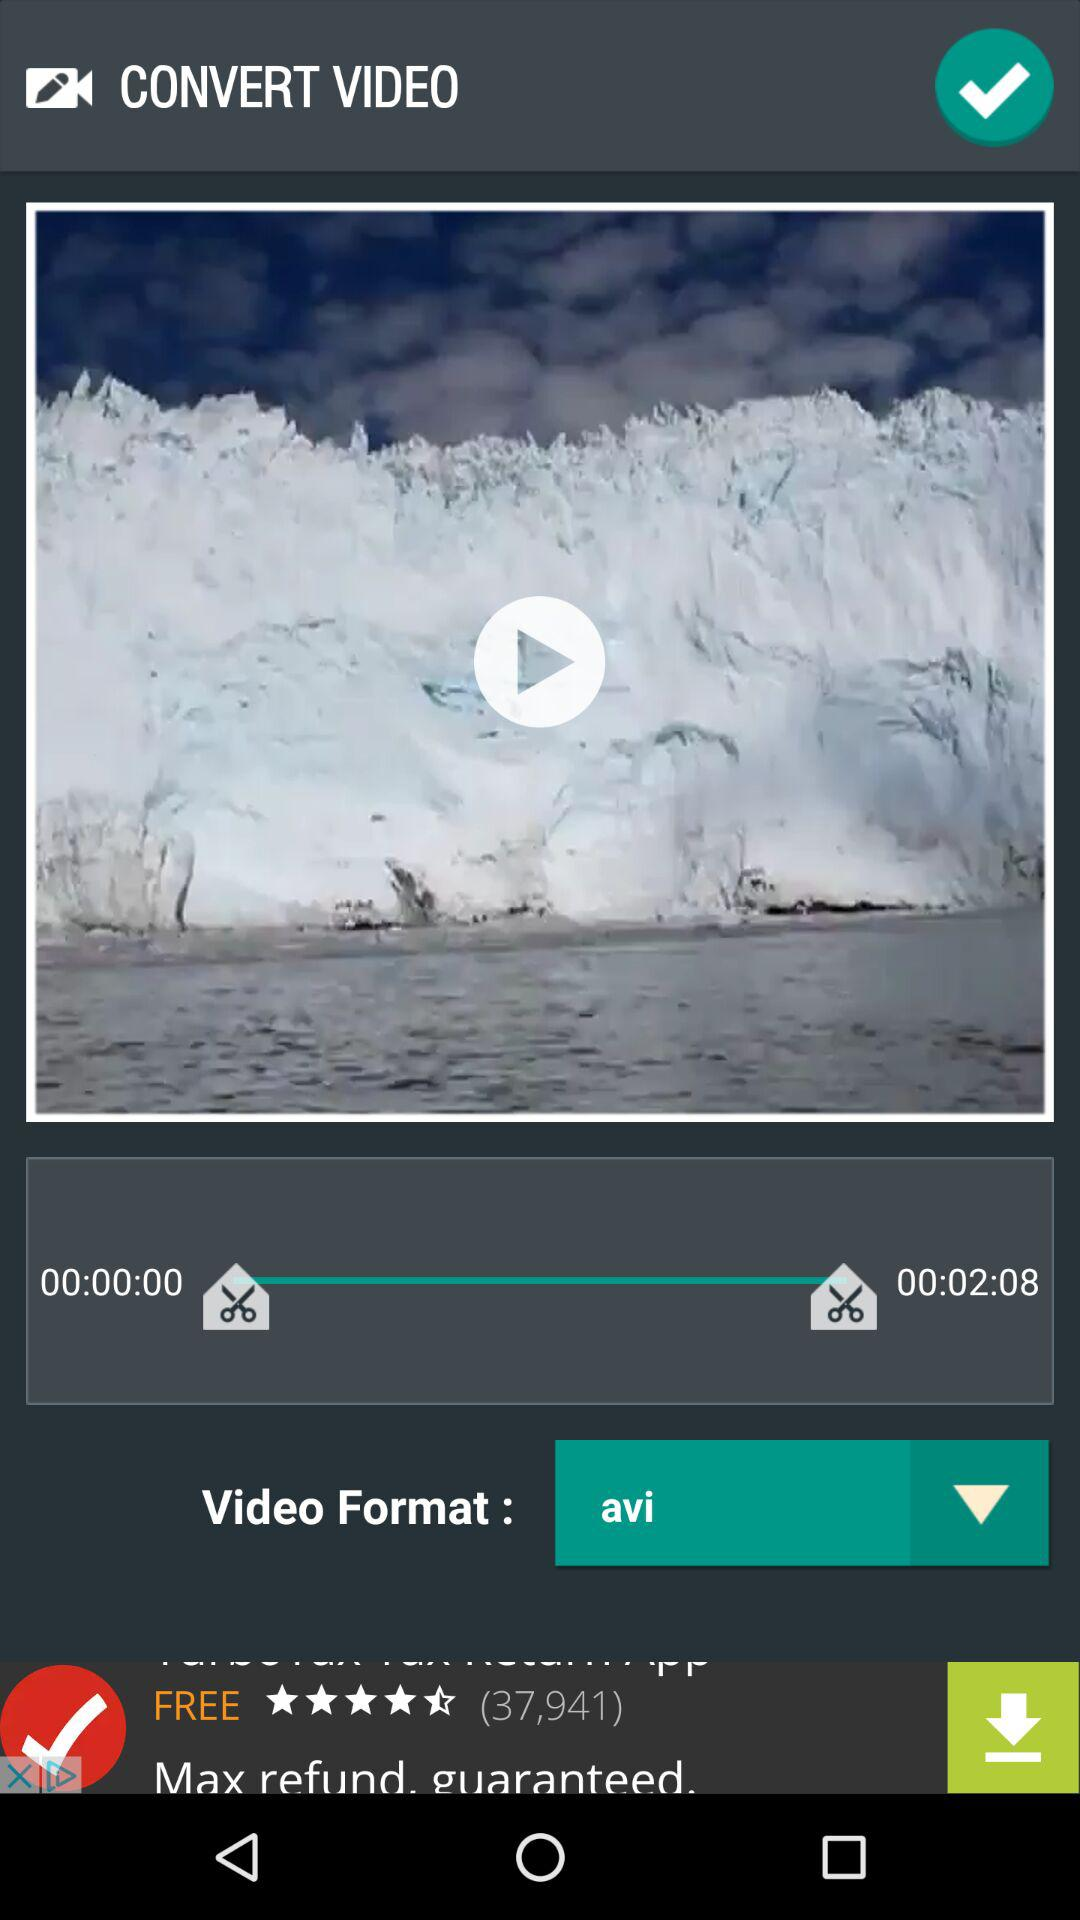Which window is open? The open window is "CONVERT VIDEO". 